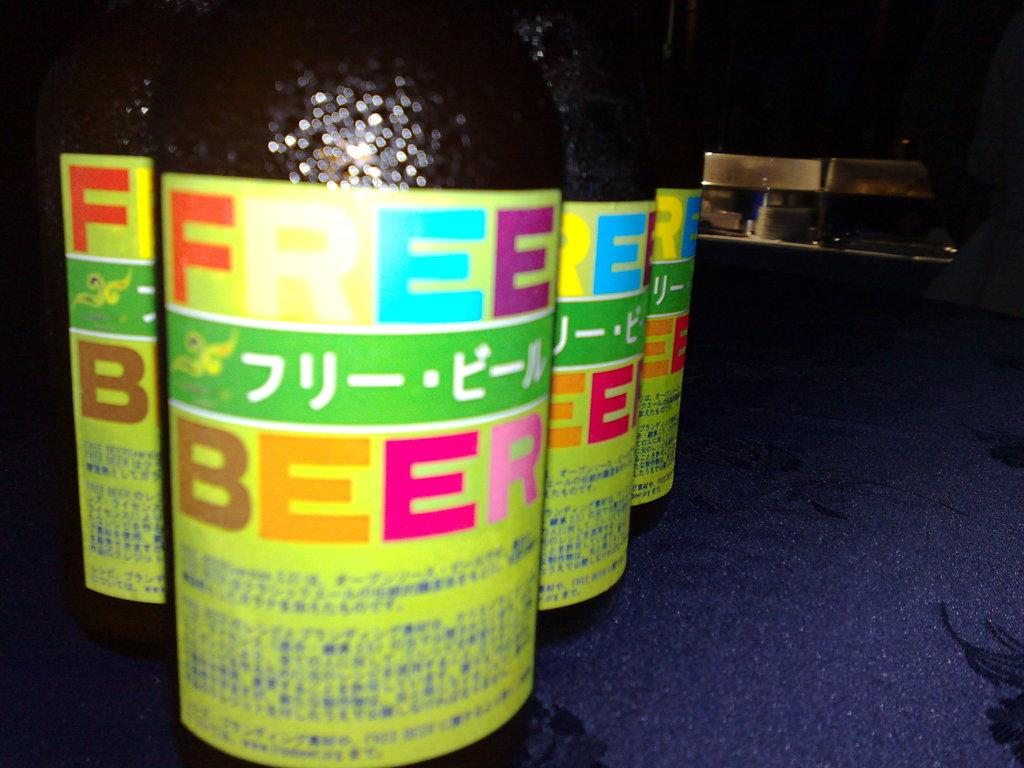What objects can be seen in the image? There are bottles in the image. What is written on the bottles? There is text written on the bottles. What type of force is being applied to the bottles in the image? There is no indication of any force being applied to the bottles in the image. 